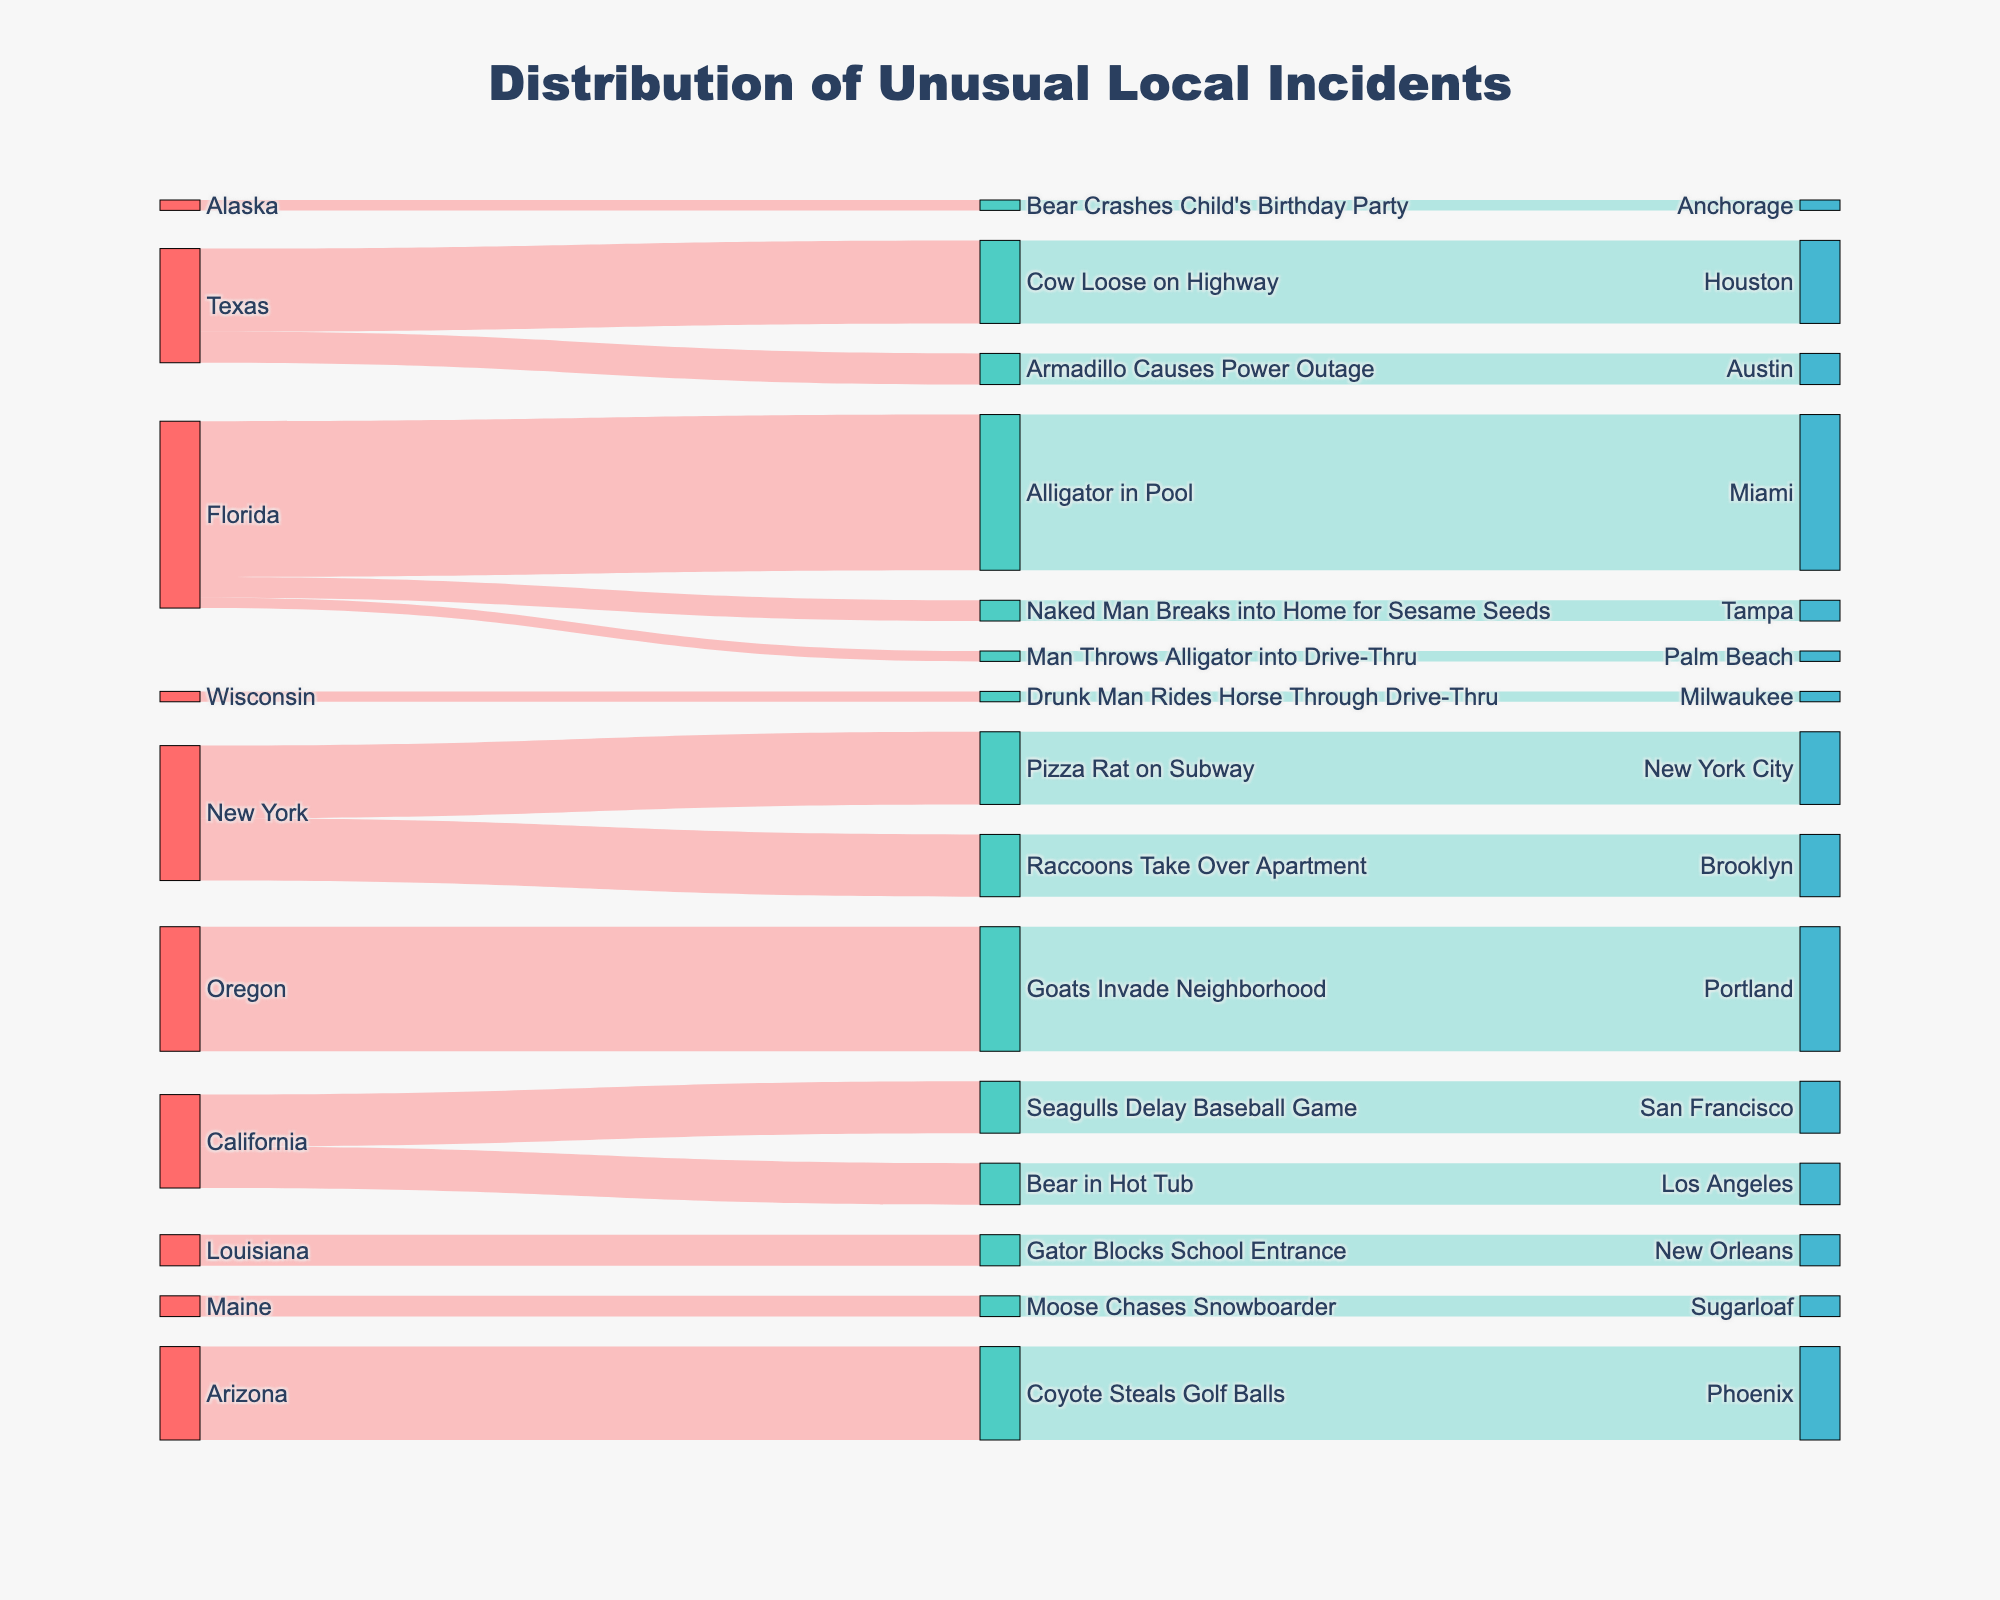Which location has the highest number of unusual local incidents? Look for the location with the highest count summarizing the links. Portland with "Goats Invade Neighborhood" has 12 incidents.
Answer: Portland How many different types of unusual incidents are reported in Florida? Count the unique types originating from Florida. Florida has 3 types: Alligator in Pool, Man Throws Alligator into Drive-Thru, and Naked Man Breaks into Home for Sesame Seeds.
Answer: 3 Which state reports an incident involving a Bear? Scan for states linking to incidents involving a Bear. California has a "Bear in Hot Tub," and Alaska has "Bear Crashes Child's Birthday Party."
Answer: California and Alaska Compare incidents: Are there more incidents involving animals or non-animal related unusual activities? Sum counts linked to animal types and non-animal types. Animal-related include Alligator, Armadillo, Cow, Seagulls, Bear, Raccoon, Goats, Coyote, Moose and totals to 76. Non-animal: Naked Man, Pizza Rat, Drunk Man and totals to 16.
Answer: More animal-related What's the total number of unusual incidents reported across all states? Sum the Count column values from all rows. Summing 15, 1, 2, 8, 3, 5, 4, 7, 6, 12, 1, 9, 3, 2, 1 total to 79.
Answer: 79 Identify which state has more occurrences: Costa Rica or Texas? Locate and sum the counts for Texas. Texas has 8 (Cow Loose on Highway) + 3 (Armadillo Causes Power Outage) = 11 occurrences. Costa Rica is not listed.
Answer: Texas What is the most frequent type of unusual incident reported in the chart? Check the Type nodes and their values linking to them. “Goats Invade Neighborhood” has the highest at 12.
Answer: Goats Invade Neighborhood Compare California: Which type of incident occurs more frequently, involving Seagulls or Bears? Summing the counts in California, Seagulls Delay Baseball Game has 5, Bear in Hot Tub has 4.
Answer: Seagulls Find the least frequently reported location and its incident type. Search the links for the minimum count. Palm Beach (Man Throws Alligator into Drive-Thru), Alaska (Bear Crashes Child's Birthday Party), and Wisconsin (Drunk Man Rides Horse Through Drive-Thru), each have counts of 1. Locations are Palm Beach, Anchorage, Milwaukee.
Answer: Palm Beach, Anchorage, Milwaukee Which kind of unusual activity links to Brooklyn? Look for the link between Types and Brooklyn. Raccoons Take Over Apartment is the relevant type.
Answer: Raccoons Take Over Apartment 